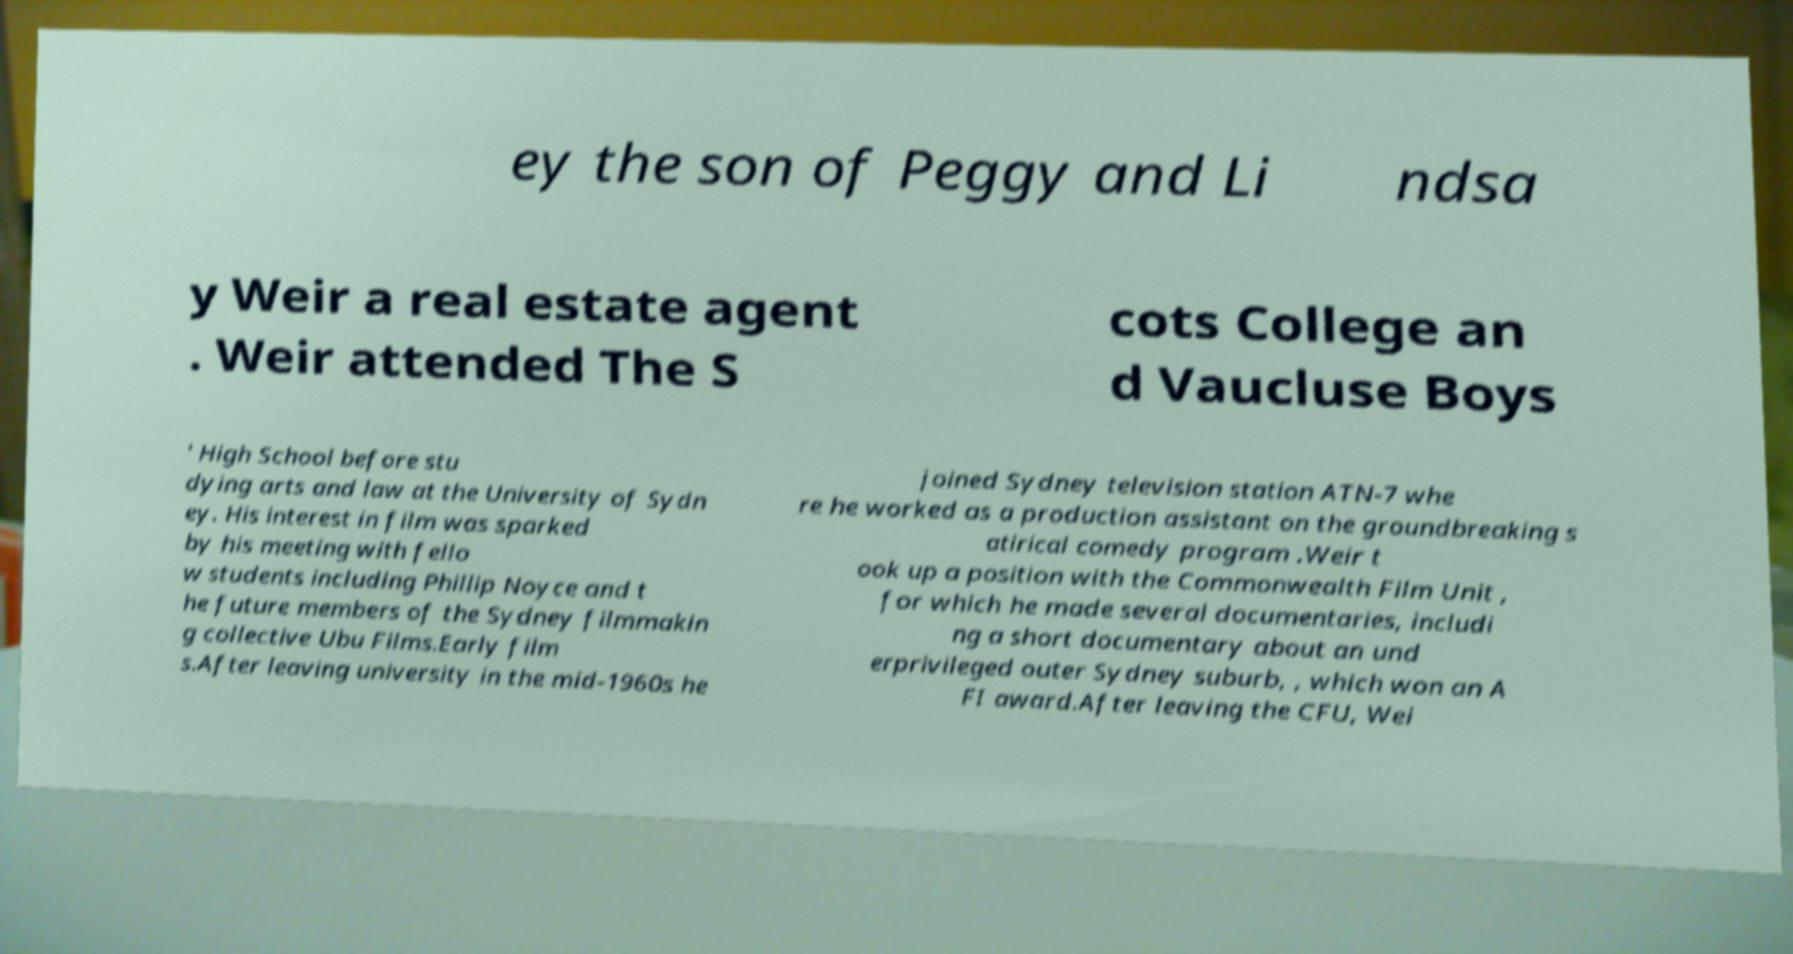I need the written content from this picture converted into text. Can you do that? ey the son of Peggy and Li ndsa y Weir a real estate agent . Weir attended The S cots College an d Vaucluse Boys ' High School before stu dying arts and law at the University of Sydn ey. His interest in film was sparked by his meeting with fello w students including Phillip Noyce and t he future members of the Sydney filmmakin g collective Ubu Films.Early film s.After leaving university in the mid-1960s he joined Sydney television station ATN-7 whe re he worked as a production assistant on the groundbreaking s atirical comedy program .Weir t ook up a position with the Commonwealth Film Unit , for which he made several documentaries, includi ng a short documentary about an und erprivileged outer Sydney suburb, , which won an A FI award.After leaving the CFU, Wei 